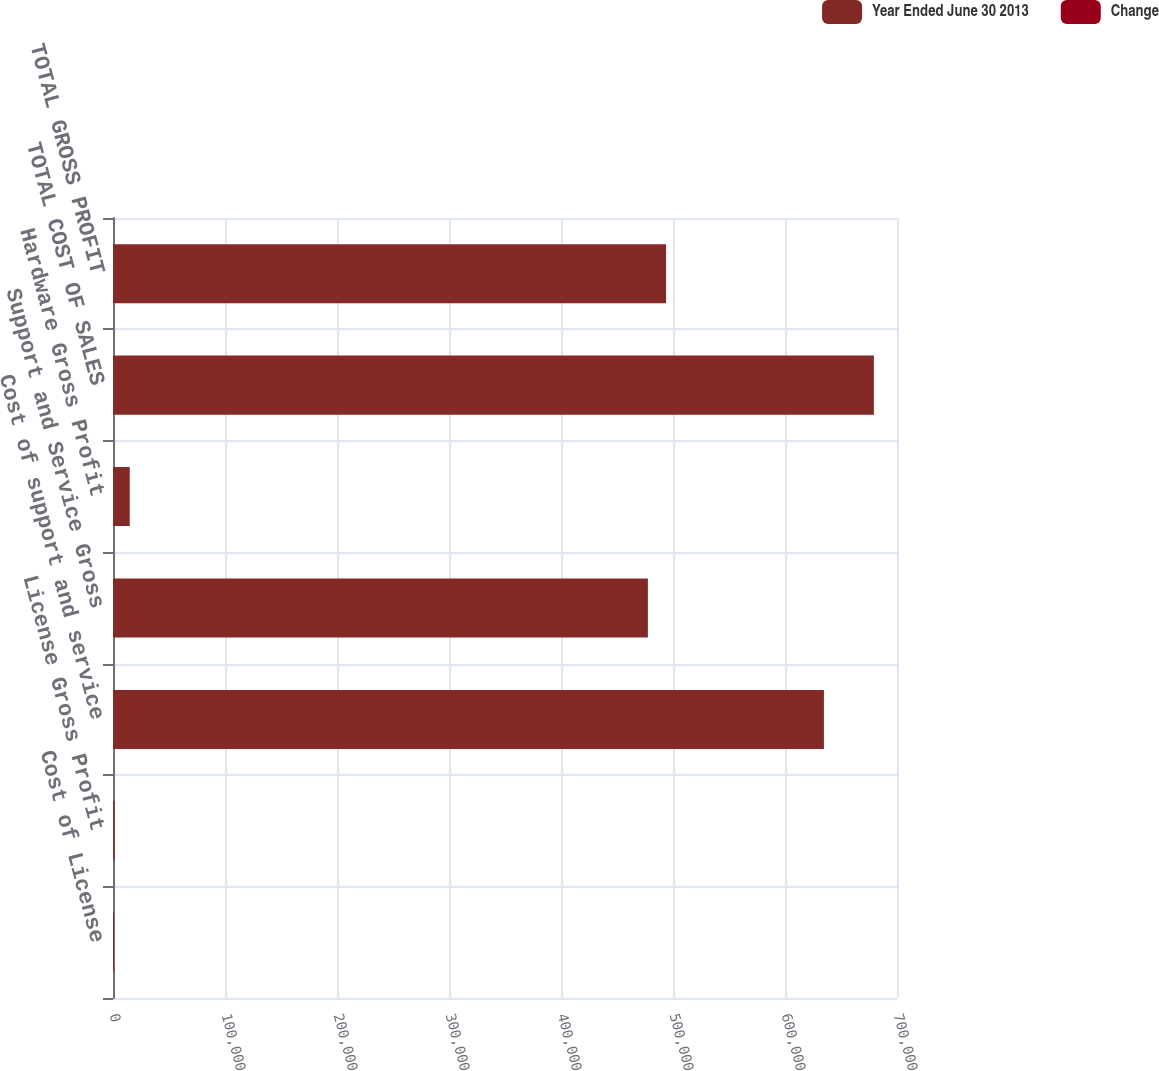Convert chart to OTSL. <chart><loc_0><loc_0><loc_500><loc_500><stacked_bar_chart><ecel><fcel>Cost of License<fcel>License Gross Profit<fcel>Cost of support and service<fcel>Support and Service Gross<fcel>Hardware Gross Profit<fcel>TOTAL COST OF SALES<fcel>TOTAL GROSS PROFIT<nl><fcel>Year Ended June 30 2013<fcel>908<fcel>1276<fcel>634756<fcel>477575<fcel>14950<fcel>679372<fcel>493801<nl><fcel>Change<fcel>6<fcel>72<fcel>6<fcel>8<fcel>5<fcel>5<fcel>7<nl></chart> 